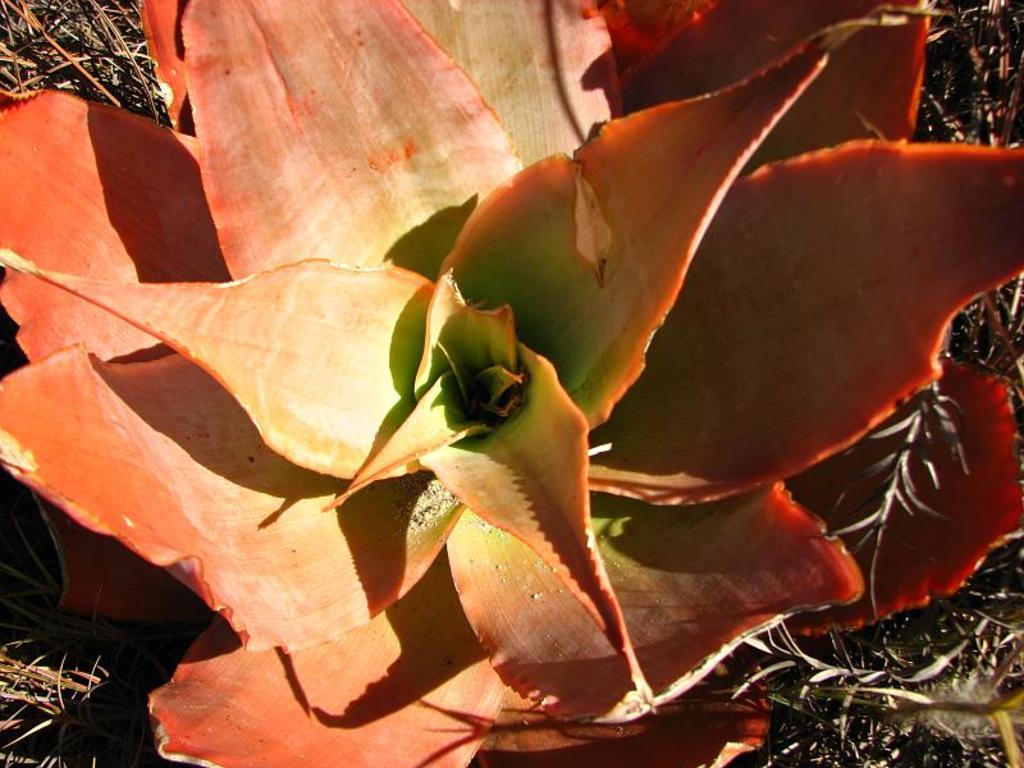What type of plant is in the image? There is a coral aloe plant in the image. What can be seen in the background of the image? There is grass in the background of the image. What type of net is being used by the army in the image? There is no army or net present in the image; it only features a coral aloe plant and grass in the background. 